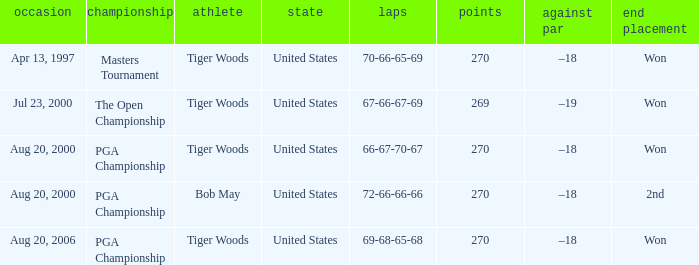What days were the rounds of 66-67-70-67 recorded? Aug 20, 2000. 